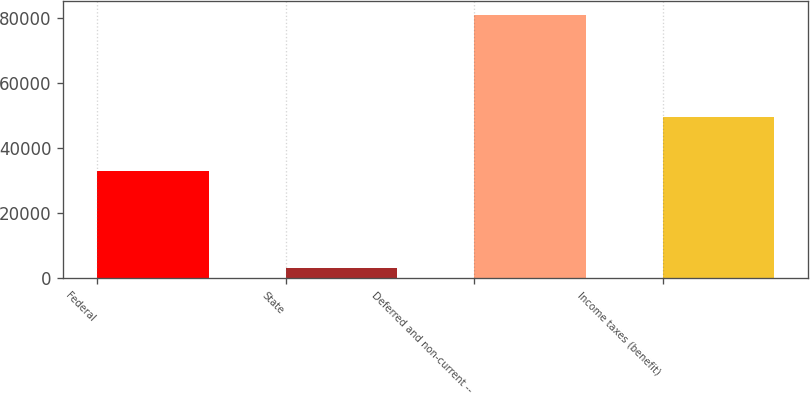<chart> <loc_0><loc_0><loc_500><loc_500><bar_chart><fcel>Federal<fcel>State<fcel>Deferred and non-current --<fcel>Income taxes (benefit)<nl><fcel>33045<fcel>3153<fcel>80993<fcel>49492<nl></chart> 